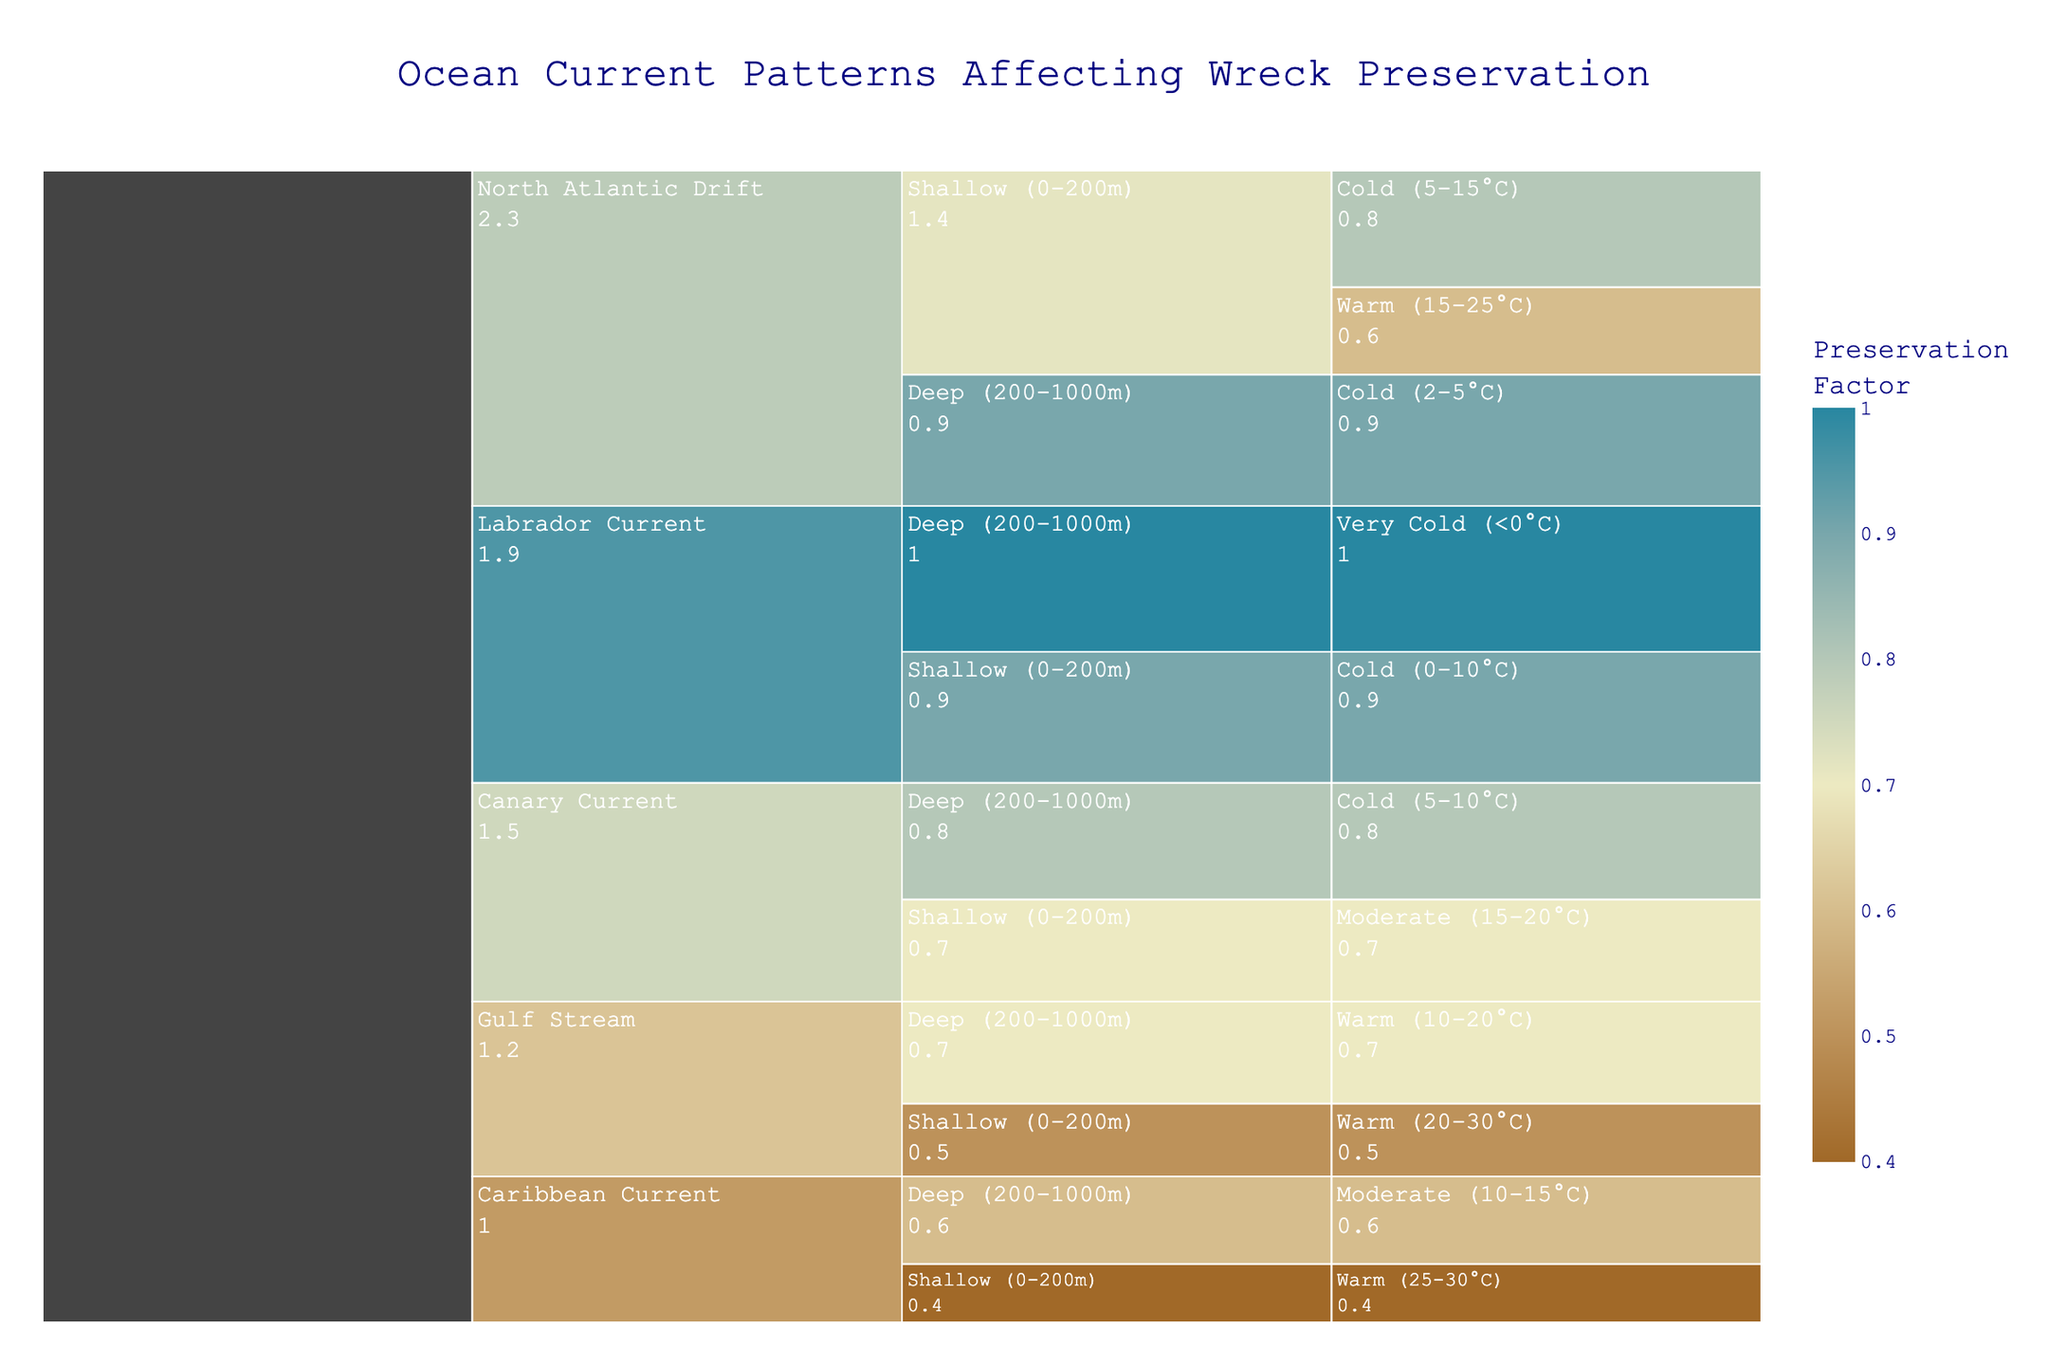How many ocean currents are analyzed in the chart? The icicle chart categorizes the data by ocean currents, which are listed as North Atlantic Drift, Gulf Stream, Labrador Current, Canary Current, and Caribbean Current. Counting each of these gives a total of 5 ocean currents.
Answer: 5 Which ocean current has the highest preservation factor in deep, cold waters? Search for the section under "Deep (200-1000m)" and "Cold (2-5°C or 5-10°C)." Among these, the "North Atlantic Drift" is listed with a preservation factor of 0.9, which is the highest.
Answer: North Atlantic Drift What is the average preservation factor for the shallow waters in the Gulf Stream? Identify the preservation factors in the Gulf Stream at shallow depths. For warm waters, the preservation factor is 0.5. There are no other categories under shallow waters for Gulf Stream in the chart. Thus, the average is just 0.5.
Answer: 0.5 Compare the preservation factors for the shallow waters in the Labrador Current and Canary Current. Which current has the higher factor, and by how much? In shallow (0-200m) waters, the Labrador Current has a preservation factor of 0.9, and the Canary Current has a preservation factor of 0.7. The difference is calculated as 0.9 - 0.7 = 0.2.
Answer: Labrador Current by 0.2 Which depth category generally shows a higher preservation factor, shallow or deep, according to the chart? To deduce this, we can look at the average preservation factors across multiple ocean currents and temperature conditions. Generally, deep water categories (like "Deep (200-1000m)") often exhibit higher preservation factors (values like 0.9 and 1.0 are seen more) compared to shallow waters, which have several lower values (like 0.4, 0.5).
Answer: Deep Among the labeled temperatures, which temperature category is associated with the highest preservation factor? The chart shows "Very Cold (<0°C)" under the Labrador Current with a preservation factor of 1.0, which is the highest among all temperatures.
Answer: Very Cold (<0°C) What is the preservation factor for the Canary Current in deep, cold waters? For the Canary Current in the section under "Deep (200-1000m)" and "Cold (5-10°C)", the preservation factor is shown as 0.8.
Answer: 0.8 For the Caribbean Current, is the preservation factor higher in shallow warm waters or deep moderate waters, and what are their values? In the Caribbean Current, the preservation factors are 0.4 for "Shallow (0-200m)" and "Warm (25-30°C)" and 0.6 for "Deep (200-1000m)" and "Moderate (10-15°C)." Thus, the deep moderate waters have a higher preservation factor, 0.6.
Answer: Deep moderate waters, 0.6 What is the title of the chart? The title is centrally located at the top of the chart and reads "Ocean Current Patterns Affecting Wreck Preservation."
Answer: Ocean Current Patterns Affecting Wreck Preservation 